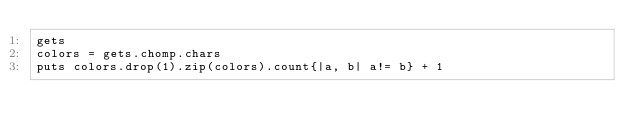Convert code to text. <code><loc_0><loc_0><loc_500><loc_500><_Ruby_>gets
colors = gets.chomp.chars
puts colors.drop(1).zip(colors).count{|a, b| a!= b} + 1
</code> 